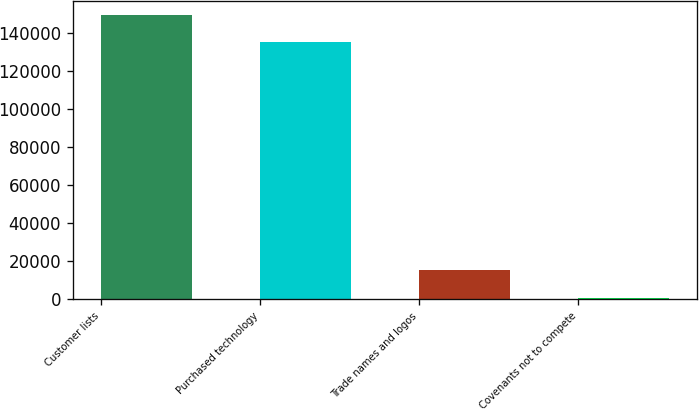Convert chart to OTSL. <chart><loc_0><loc_0><loc_500><loc_500><bar_chart><fcel>Customer lists<fcel>Purchased technology<fcel>Trade names and logos<fcel>Covenants not to compete<nl><fcel>149330<fcel>134800<fcel>15230<fcel>700<nl></chart> 